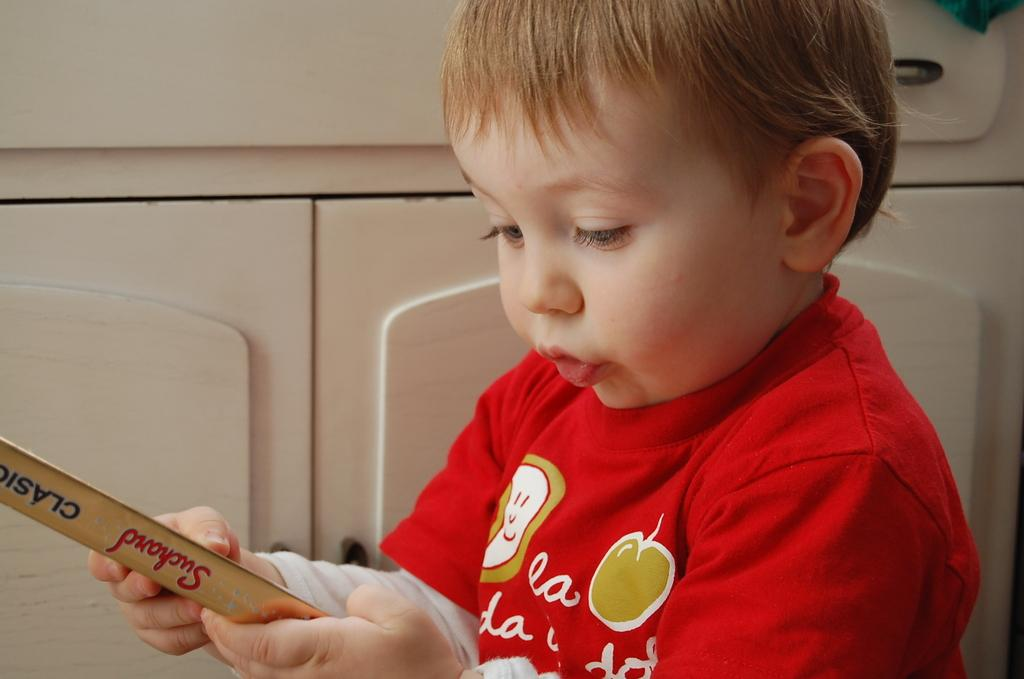What is the main subject of the image? The main subject of the image is a kid. What is the kid doing in the image? The kid is holding an object. What type of kitten is the manager of the birds in the image? There is no kitten, manager, or birds present in the image. 